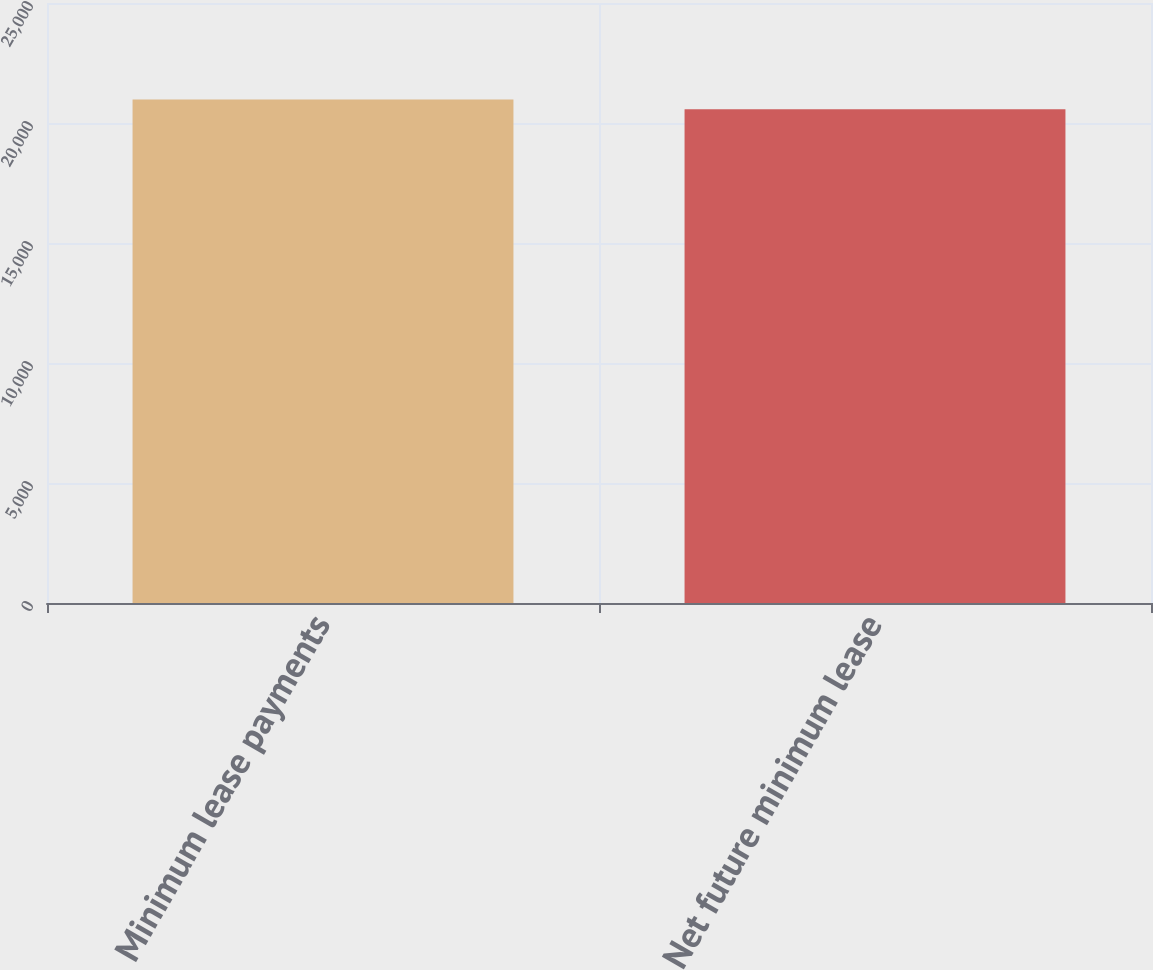Convert chart. <chart><loc_0><loc_0><loc_500><loc_500><bar_chart><fcel>Minimum lease payments<fcel>Net future minimum lease<nl><fcel>20978<fcel>20571<nl></chart> 